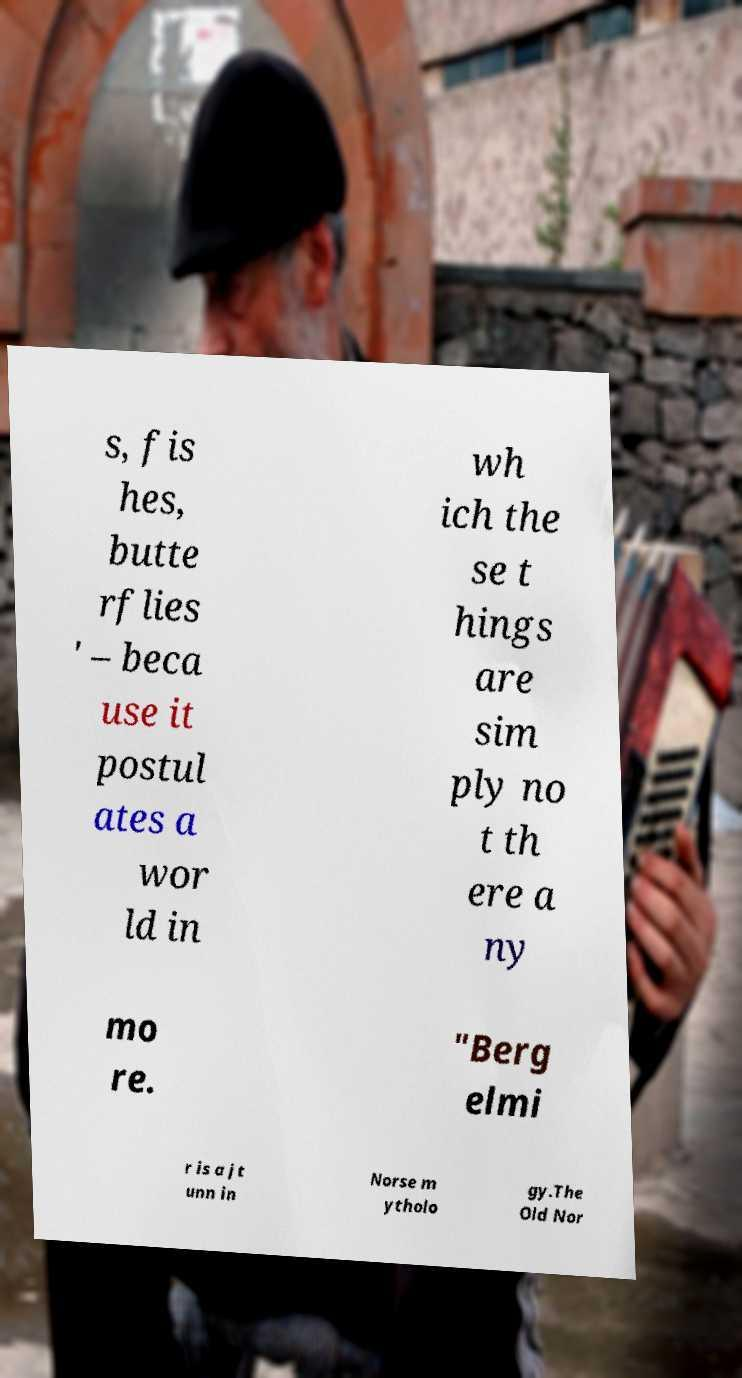Can you read and provide the text displayed in the image?This photo seems to have some interesting text. Can you extract and type it out for me? s, fis hes, butte rflies ' – beca use it postul ates a wor ld in wh ich the se t hings are sim ply no t th ere a ny mo re. "Berg elmi r is a jt unn in Norse m ytholo gy.The Old Nor 